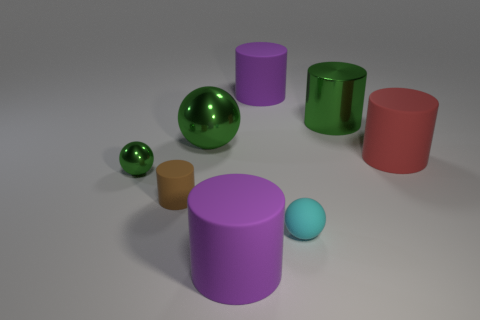Subtract all green cylinders. How many cylinders are left? 4 Subtract all green shiny cylinders. How many cylinders are left? 4 Subtract 1 cylinders. How many cylinders are left? 4 Subtract all cyan cylinders. Subtract all purple blocks. How many cylinders are left? 5 Add 1 red metal blocks. How many objects exist? 9 Subtract all cylinders. How many objects are left? 3 Add 1 brown things. How many brown things exist? 2 Subtract 0 cyan blocks. How many objects are left? 8 Subtract all large green metal cylinders. Subtract all green metal cylinders. How many objects are left? 6 Add 8 large green things. How many large green things are left? 10 